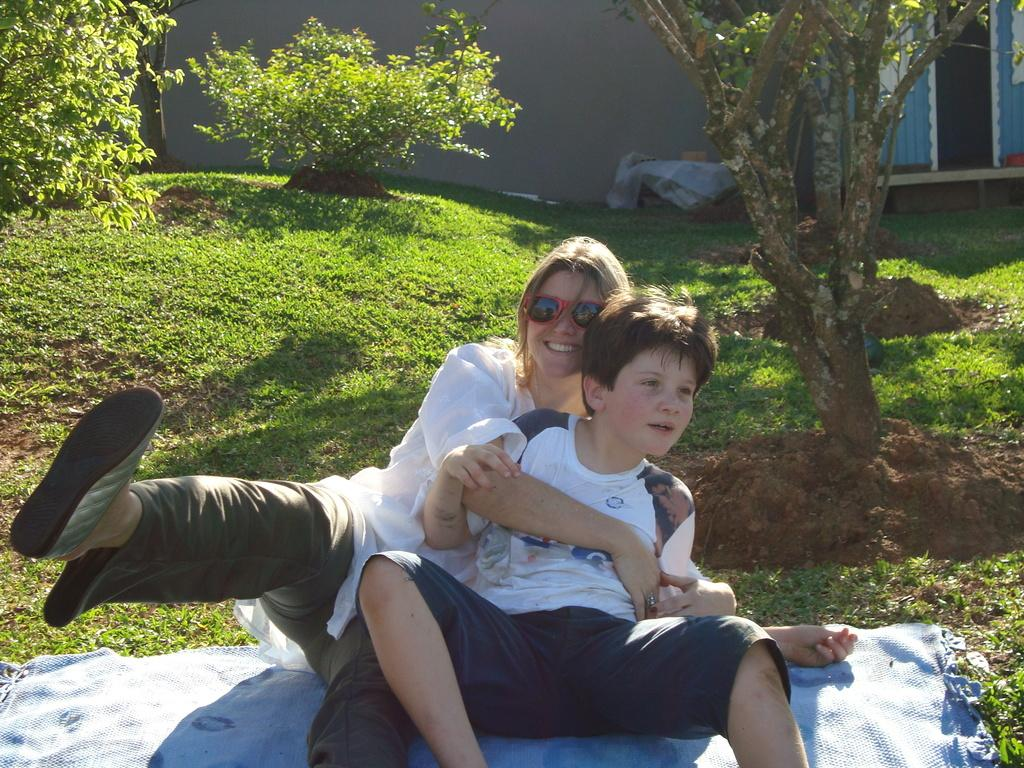Who are the people in the image? There is a boy and a woman in the image. What are they doing in the image? They are sitting on the ground. What can be seen in the background of the image? There are trees, plants, grass, and a building in the background of the image. How many dogs are sitting with the boy and woman in the image? There are no dogs present in the image. What type of plant is the boy holding in the image? There is no plant visible in the image, and the boy is not holding anything. 